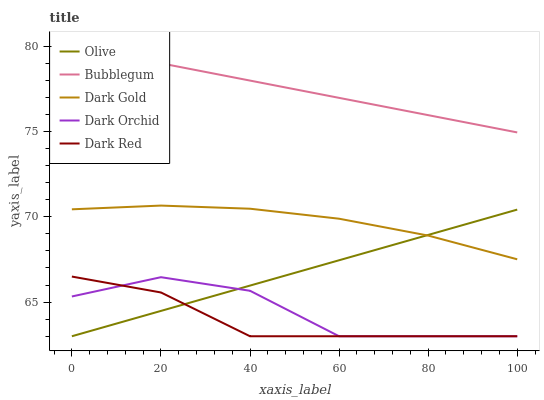Does Dark Red have the minimum area under the curve?
Answer yes or no. Yes. Does Bubblegum have the maximum area under the curve?
Answer yes or no. Yes. Does Dark Orchid have the minimum area under the curve?
Answer yes or no. No. Does Dark Orchid have the maximum area under the curve?
Answer yes or no. No. Is Olive the smoothest?
Answer yes or no. Yes. Is Dark Orchid the roughest?
Answer yes or no. Yes. Is Dark Red the smoothest?
Answer yes or no. No. Is Dark Red the roughest?
Answer yes or no. No. Does Olive have the lowest value?
Answer yes or no. Yes. Does Bubblegum have the lowest value?
Answer yes or no. No. Does Bubblegum have the highest value?
Answer yes or no. Yes. Does Dark Red have the highest value?
Answer yes or no. No. Is Dark Red less than Dark Gold?
Answer yes or no. Yes. Is Bubblegum greater than Dark Gold?
Answer yes or no. Yes. Does Olive intersect Dark Gold?
Answer yes or no. Yes. Is Olive less than Dark Gold?
Answer yes or no. No. Is Olive greater than Dark Gold?
Answer yes or no. No. Does Dark Red intersect Dark Gold?
Answer yes or no. No. 